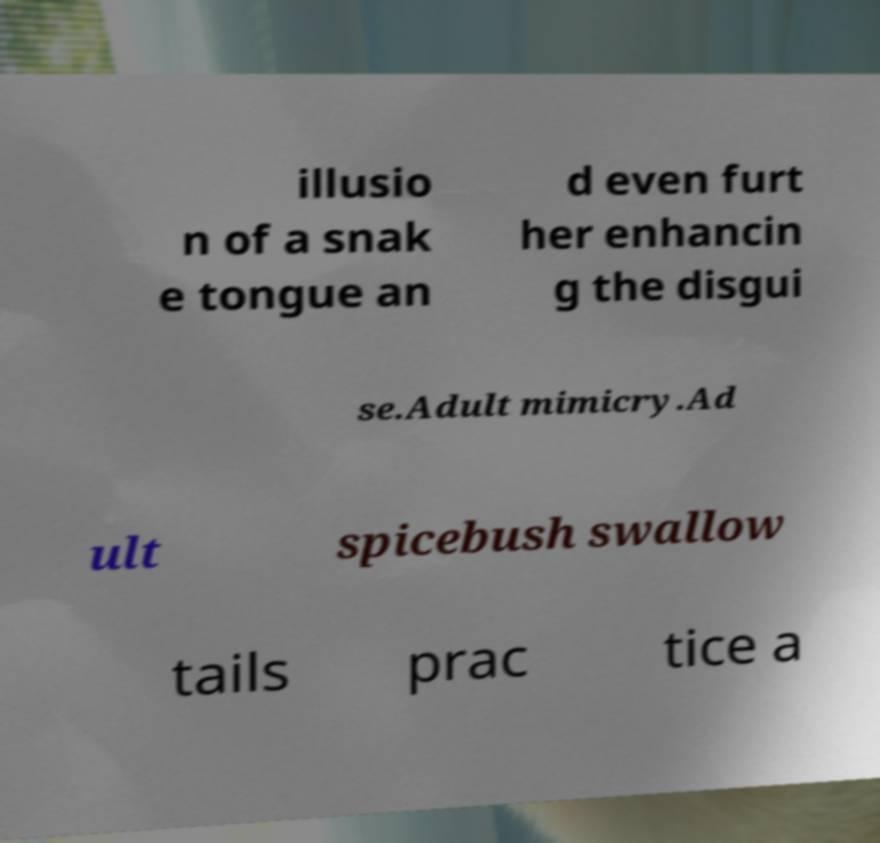Can you read and provide the text displayed in the image?This photo seems to have some interesting text. Can you extract and type it out for me? illusio n of a snak e tongue an d even furt her enhancin g the disgui se.Adult mimicry.Ad ult spicebush swallow tails prac tice a 